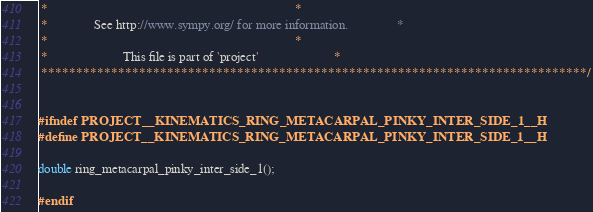<code> <loc_0><loc_0><loc_500><loc_500><_C_> *                                                                            *
 *              See http://www.sympy.org/ for more information.               *
 *                                                                            *
 *                       This file is part of 'project'                       *
 ******************************************************************************/


#ifndef PROJECT__KINEMATICS_RING_METACARPAL_PINKY_INTER_SIDE_1__H
#define PROJECT__KINEMATICS_RING_METACARPAL_PINKY_INTER_SIDE_1__H

double ring_metacarpal_pinky_inter_side_1();

#endif

</code> 